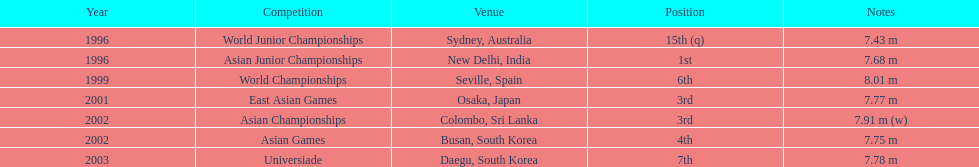In what year was his most impressive jump recorded? 1999. 